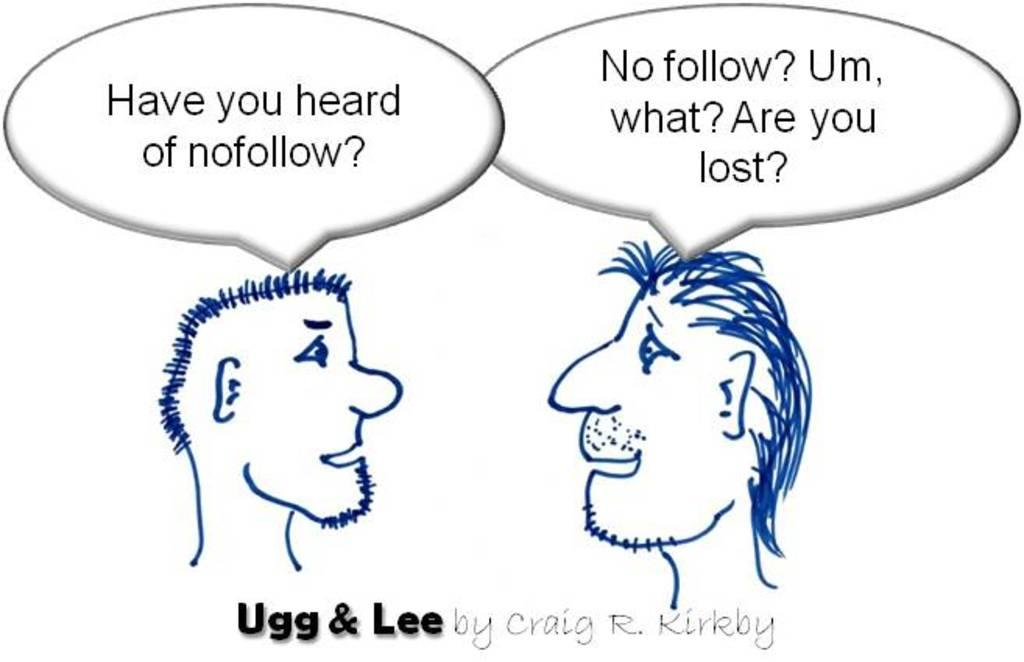What is depicted in the image? There is a sketch of two persons in the image. What else can be seen in the image besides the sketch? There are words visible in the image. What is the color of the background in the image? The background of the image is white. What type of belief is being expressed by the visitor in the image? There is no visitor present in the image, and therefore no belief can be attributed to them. 